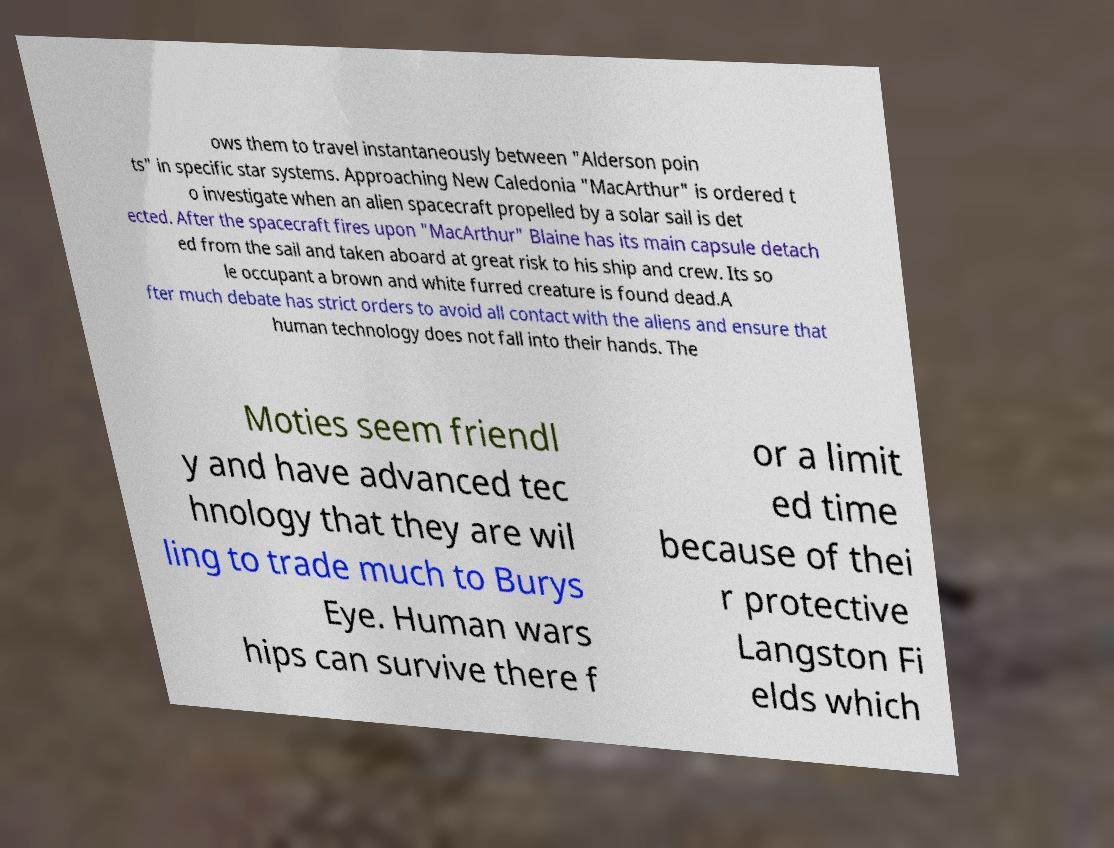There's text embedded in this image that I need extracted. Can you transcribe it verbatim? ows them to travel instantaneously between "Alderson poin ts" in specific star systems. Approaching New Caledonia "MacArthur" is ordered t o investigate when an alien spacecraft propelled by a solar sail is det ected. After the spacecraft fires upon "MacArthur" Blaine has its main capsule detach ed from the sail and taken aboard at great risk to his ship and crew. Its so le occupant a brown and white furred creature is found dead.A fter much debate has strict orders to avoid all contact with the aliens and ensure that human technology does not fall into their hands. The Moties seem friendl y and have advanced tec hnology that they are wil ling to trade much to Burys Eye. Human wars hips can survive there f or a limit ed time because of thei r protective Langston Fi elds which 